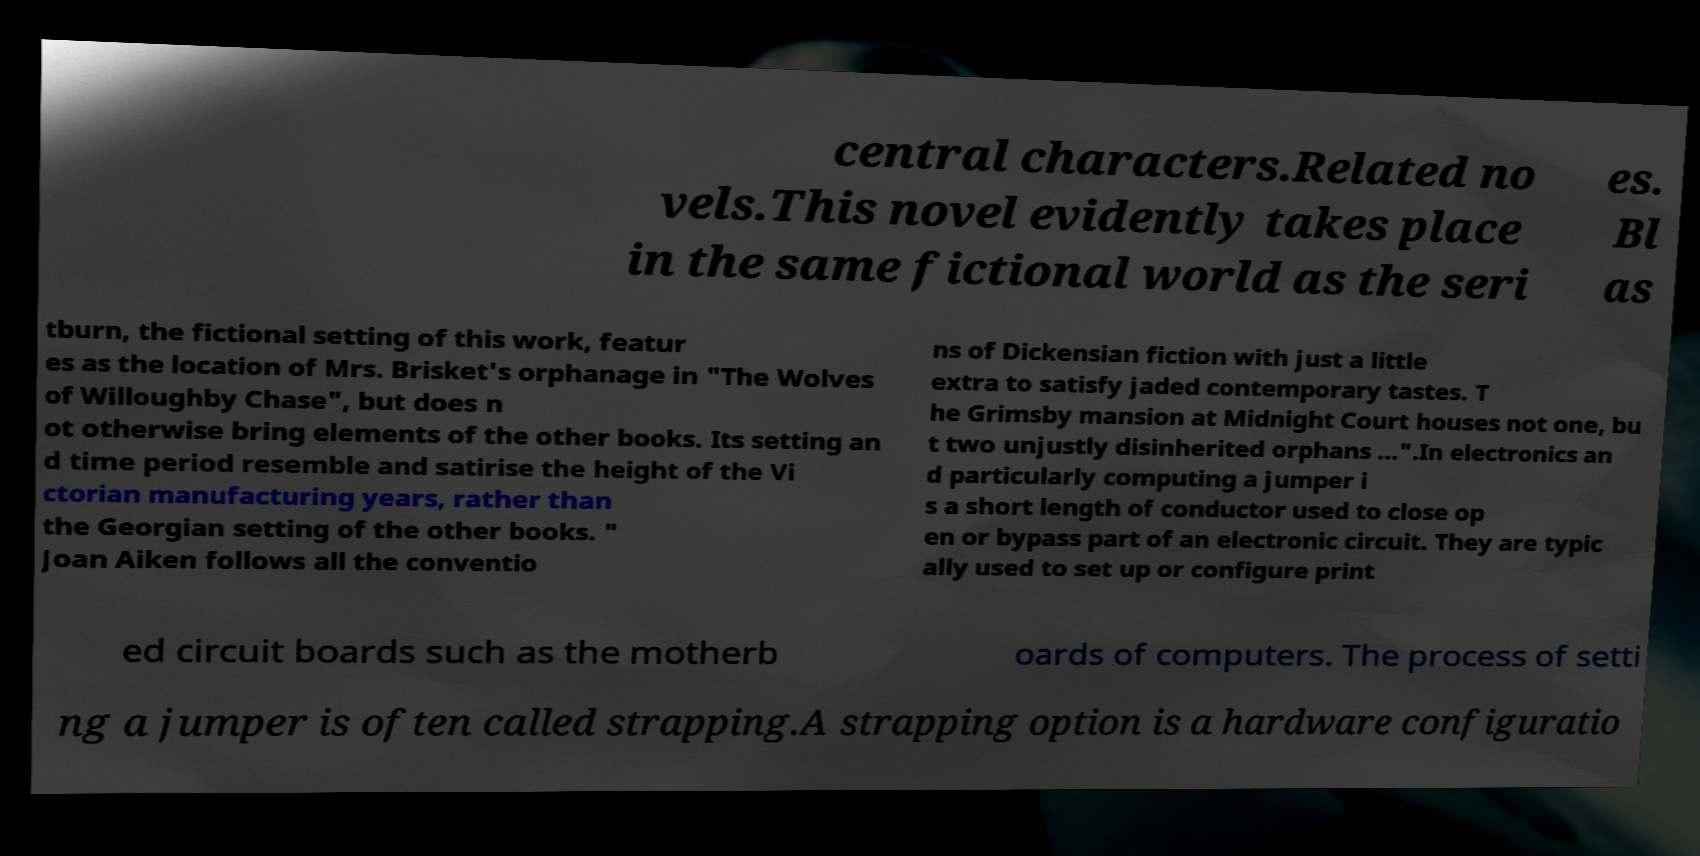There's text embedded in this image that I need extracted. Can you transcribe it verbatim? central characters.Related no vels.This novel evidently takes place in the same fictional world as the seri es. Bl as tburn, the fictional setting of this work, featur es as the location of Mrs. Brisket's orphanage in "The Wolves of Willoughby Chase", but does n ot otherwise bring elements of the other books. Its setting an d time period resemble and satirise the height of the Vi ctorian manufacturing years, rather than the Georgian setting of the other books. " Joan Aiken follows all the conventio ns of Dickensian fiction with just a little extra to satisfy jaded contemporary tastes. T he Grimsby mansion at Midnight Court houses not one, bu t two unjustly disinherited orphans ...".In electronics an d particularly computing a jumper i s a short length of conductor used to close op en or bypass part of an electronic circuit. They are typic ally used to set up or configure print ed circuit boards such as the motherb oards of computers. The process of setti ng a jumper is often called strapping.A strapping option is a hardware configuratio 